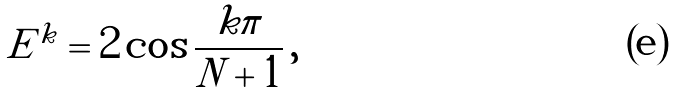<formula> <loc_0><loc_0><loc_500><loc_500>E ^ { k } = 2 \cos \frac { k \pi } { N + 1 } \, ,</formula> 